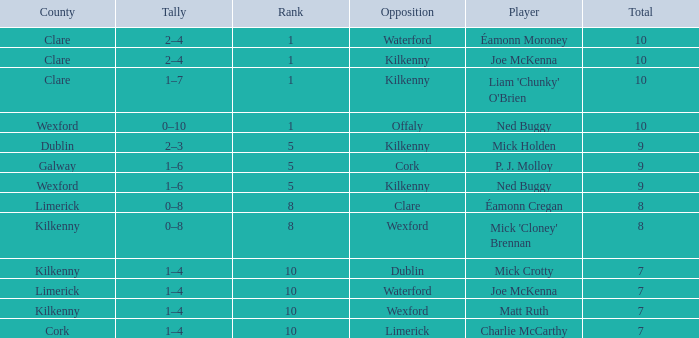Which Total has a County of kilkenny, and a Tally of 1–4, and a Rank larger than 10? None. 